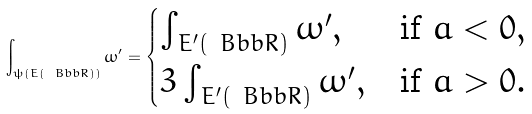<formula> <loc_0><loc_0><loc_500><loc_500>\int _ { \psi ( E ( \ B b b R ) ) } \omega ^ { \prime } = \begin{cases} \int _ { E ^ { \prime } ( \ B b b R ) } \omega ^ { \prime } , & \text {if $a<0$} , \\ 3 \int _ { E ^ { \prime } ( \ B b b R ) } \omega ^ { \prime } , & \text {if $a>0$} . \end{cases}</formula> 